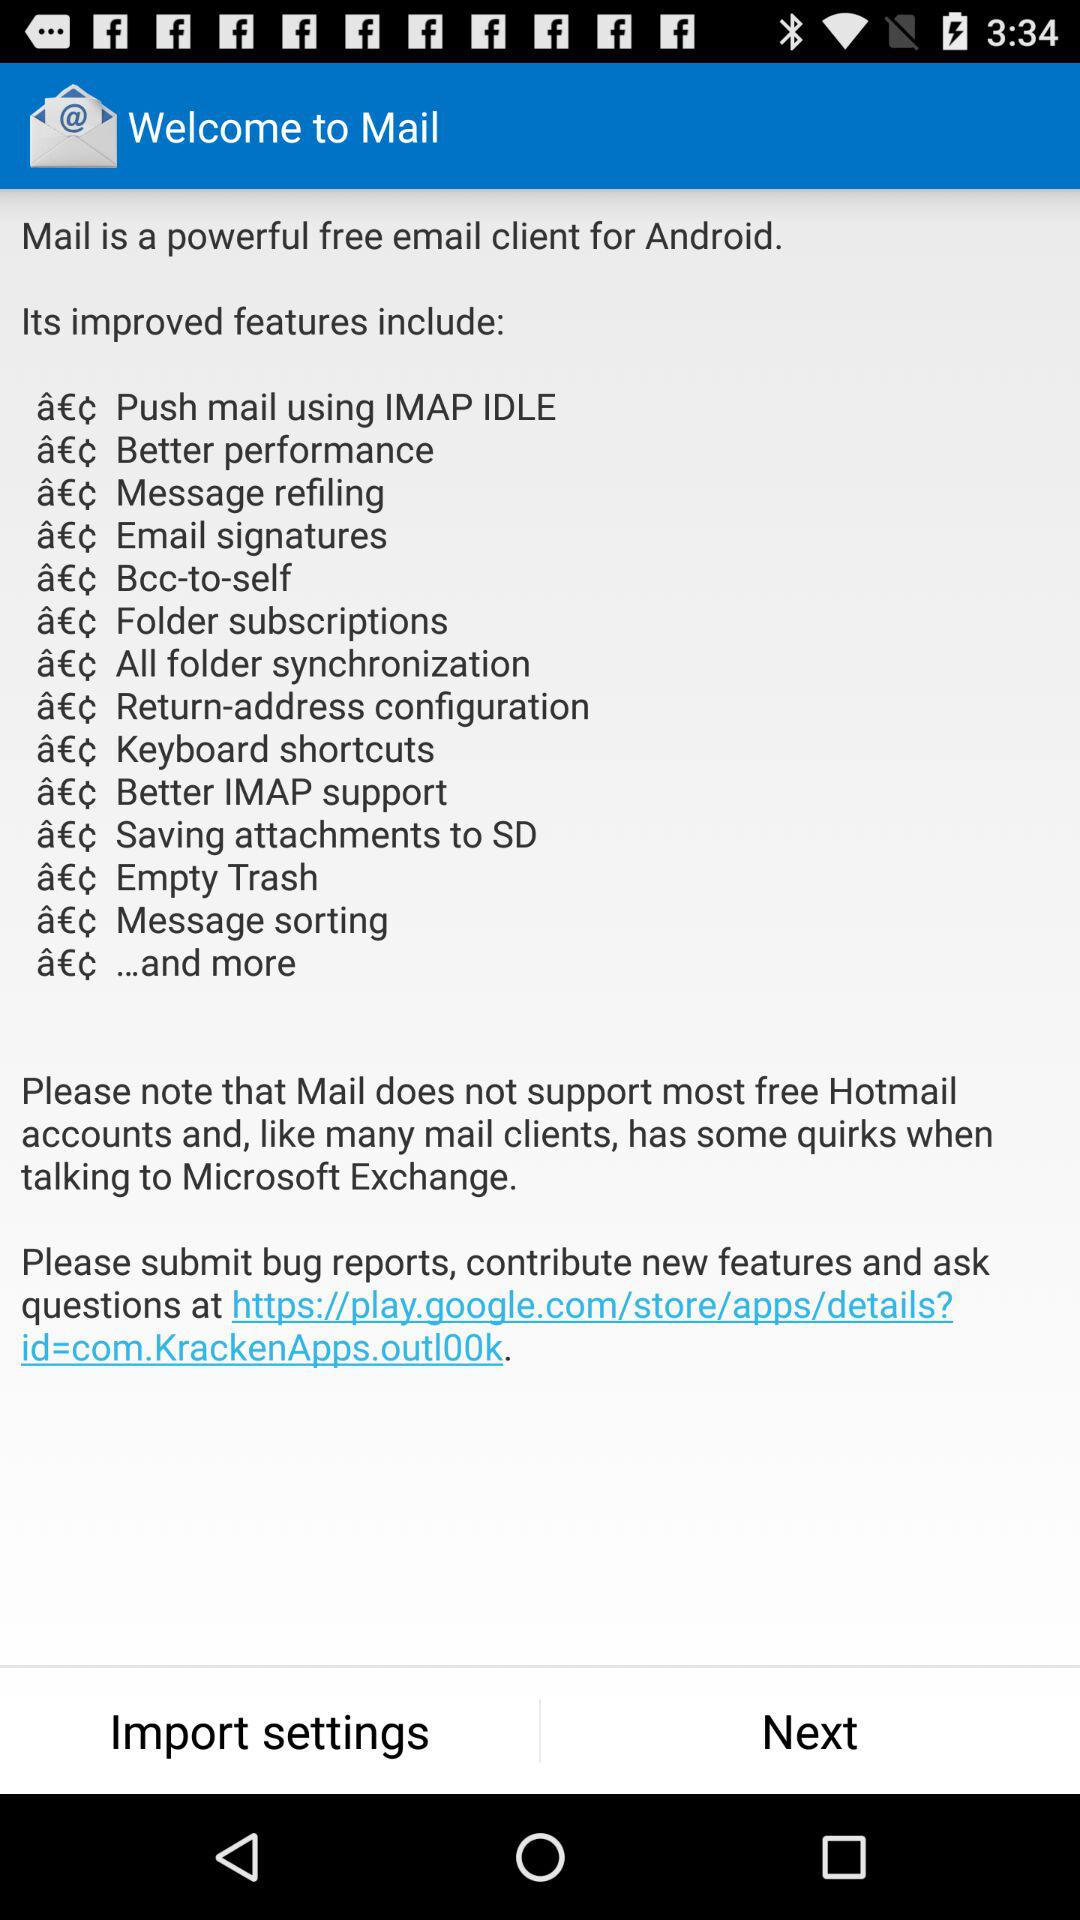What are the different improved features of "Mail"? The different improved features of "Mail" are "Push mail using IMAP IDLE", "Better performance", "Message refiling", "Email signatures", "Bcc-to-self", "Folder subscriptions", "All folder synchronization", "Return-address configuration", "Keyboard shortcuts", "Better IMAP support", "Saving attachments to SD", "Empty Trash", "Message sorting" and "...and more". 